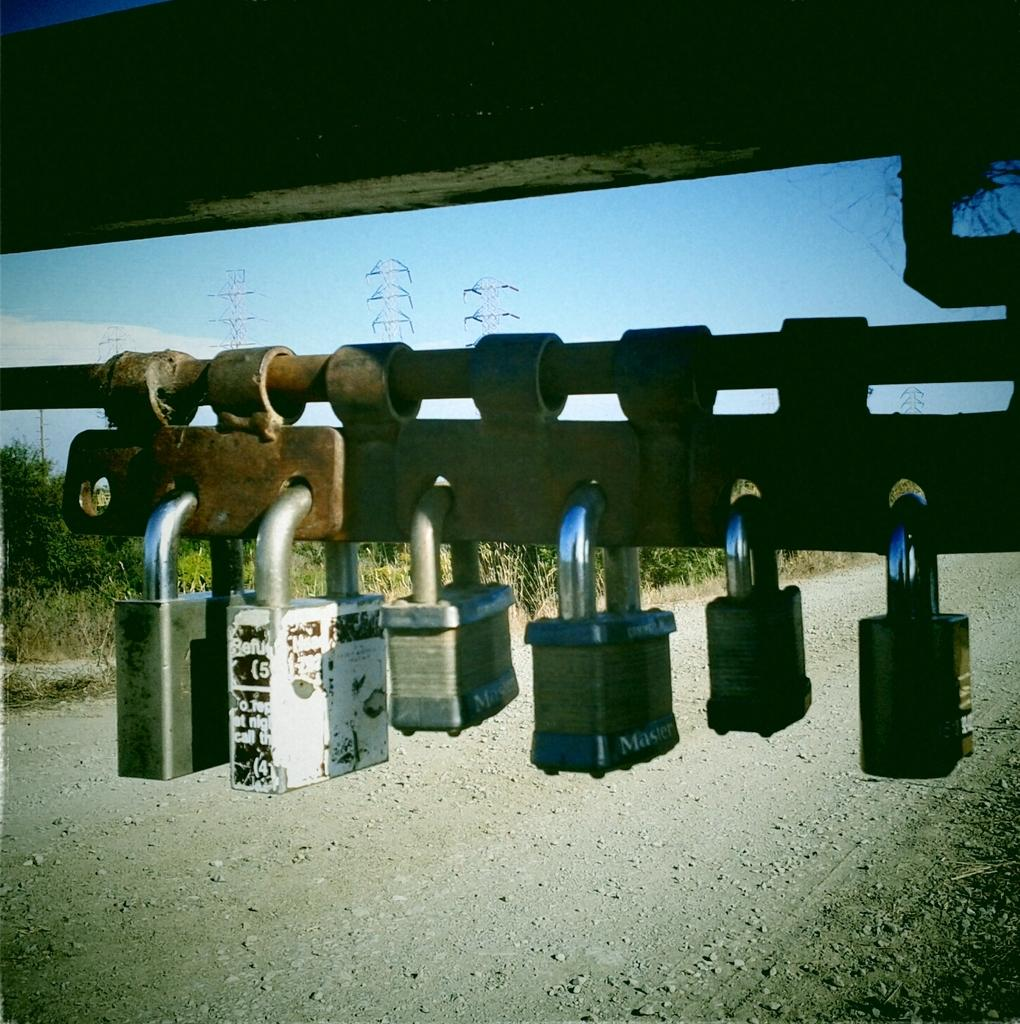What is the metal object with locks in the image? The facts do not specify the type of metal object with locks, so we cannot determine its identity. What type of plants are in the image? The facts do not specify the type of plants, so we cannot determine their identity. What can be seen on the ground in the image? There is a road in the image. What is visible in the background of the image? There are towers and the sky visible in the background of the image. Can you tell me how many potatoes are in the image? There are no potatoes present in the image. What type of clouds can be seen in the image? The facts do not mention any clouds in the image, so we cannot determine their type. 